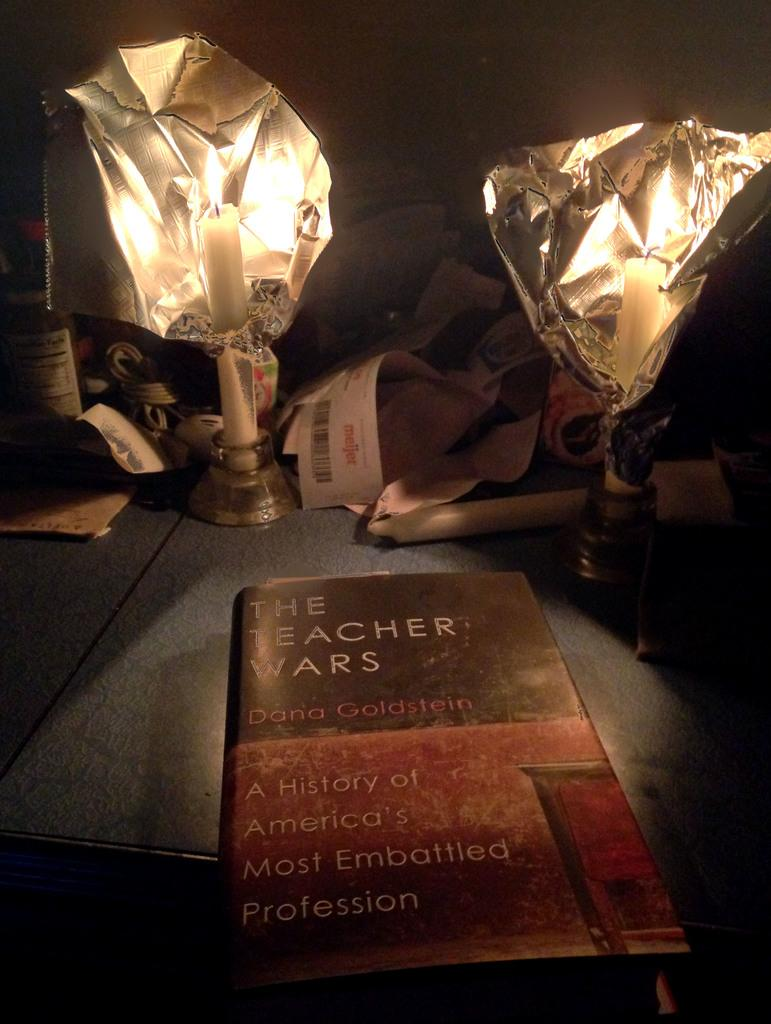<image>
Summarize the visual content of the image. A book on a table titled The Teacher Wars. 